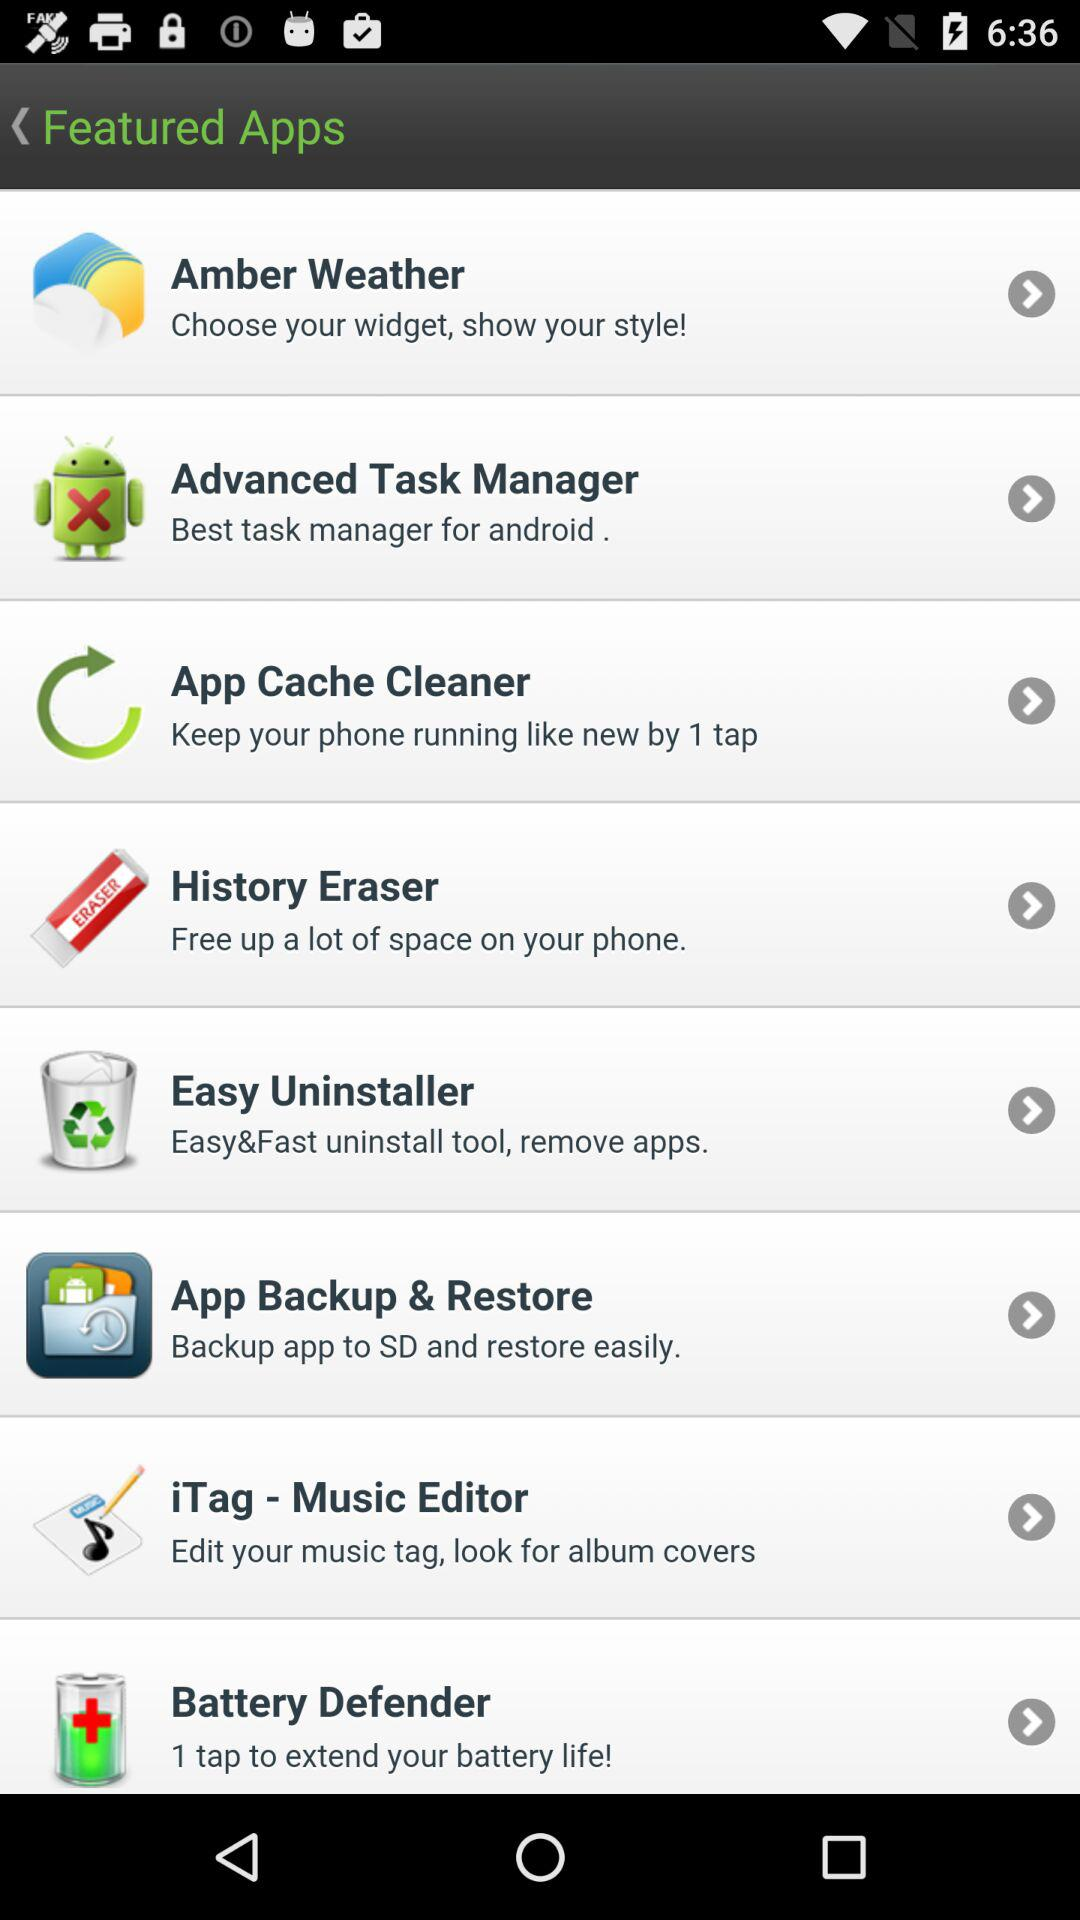What application can we use to extend battery life? The application is "Battery Defender". 